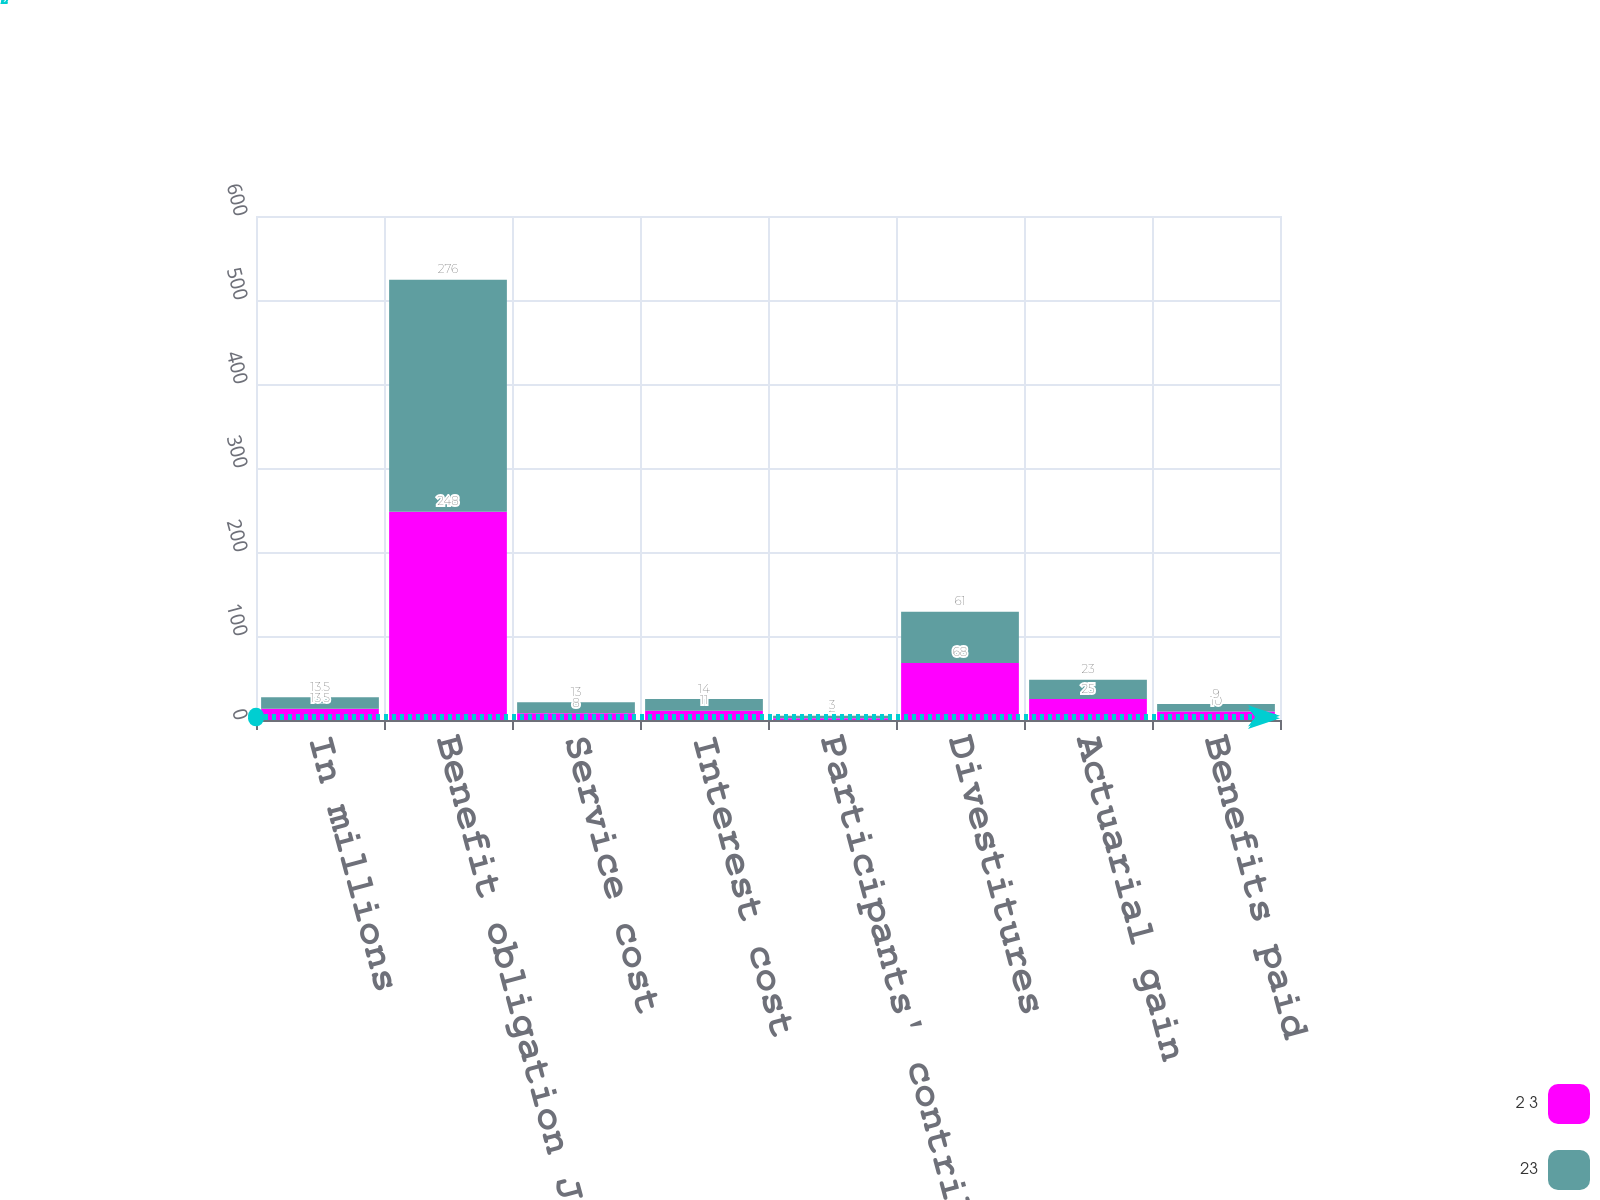<chart> <loc_0><loc_0><loc_500><loc_500><stacked_bar_chart><ecel><fcel>In millions<fcel>Benefit obligation January 1<fcel>Service cost<fcel>Interest cost<fcel>Participants' contributions<fcel>Divestitures<fcel>Actuarial gain<fcel>Benefits paid<nl><fcel>2 3<fcel>13.5<fcel>248<fcel>8<fcel>11<fcel>2<fcel>68<fcel>25<fcel>10<nl><fcel>23<fcel>13.5<fcel>276<fcel>13<fcel>14<fcel>3<fcel>61<fcel>23<fcel>9<nl></chart> 